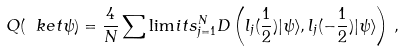Convert formula to latex. <formula><loc_0><loc_0><loc_500><loc_500>Q ( \ k e t { \psi } ) = \frac { 4 } { N } \sum \lim i t s _ { j = 1 } ^ { N } D \left ( l _ { j } ( \frac { 1 } { 2 } ) | \psi \rangle , l _ { j } ( - \frac { 1 } { 2 } ) | \psi \rangle \right ) \, ,</formula> 